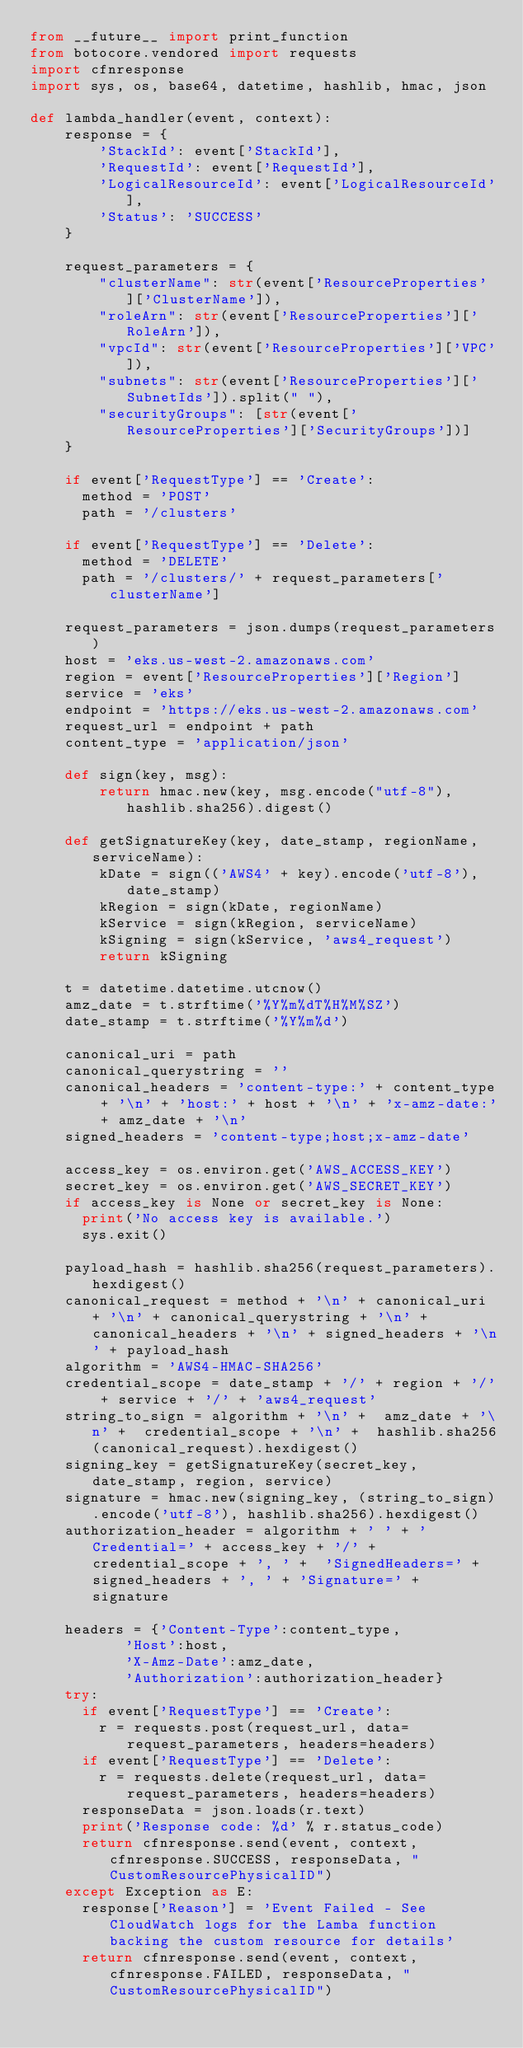Convert code to text. <code><loc_0><loc_0><loc_500><loc_500><_Python_>from __future__ import print_function
from botocore.vendored import requests
import cfnresponse
import sys, os, base64, datetime, hashlib, hmac, json

def lambda_handler(event, context):
    response = {
        'StackId': event['StackId'],
        'RequestId': event['RequestId'],
        'LogicalResourceId': event['LogicalResourceId'],
        'Status': 'SUCCESS'
    }

    request_parameters = {
        "clusterName": str(event['ResourceProperties']['ClusterName']),
        "roleArn": str(event['ResourceProperties']['RoleArn']),
        "vpcId": str(event['ResourceProperties']['VPC']),
        "subnets": str(event['ResourceProperties']['SubnetIds']).split(" "),
        "securityGroups": [str(event['ResourceProperties']['SecurityGroups'])]
    }

    if event['RequestType'] == 'Create':
      method = 'POST'
      path = '/clusters'

    if event['RequestType'] == 'Delete':
      method = 'DELETE'
      path = '/clusters/' + request_parameters['clusterName']

    request_parameters = json.dumps(request_parameters)
    host = 'eks.us-west-2.amazonaws.com'
    region = event['ResourceProperties']['Region']
    service = 'eks'
    endpoint = 'https://eks.us-west-2.amazonaws.com'
    request_url = endpoint + path
    content_type = 'application/json'

    def sign(key, msg):
        return hmac.new(key, msg.encode("utf-8"), hashlib.sha256).digest()

    def getSignatureKey(key, date_stamp, regionName, serviceName):
        kDate = sign(('AWS4' + key).encode('utf-8'), date_stamp)
        kRegion = sign(kDate, regionName)
        kService = sign(kRegion, serviceName)
        kSigning = sign(kService, 'aws4_request')
        return kSigning
    
    t = datetime.datetime.utcnow()
    amz_date = t.strftime('%Y%m%dT%H%M%SZ')
    date_stamp = t.strftime('%Y%m%d')

    canonical_uri = path
    canonical_querystring = ''               
    canonical_headers = 'content-type:' + content_type + '\n' + 'host:' + host + '\n' + 'x-amz-date:' + amz_date + '\n'
    signed_headers = 'content-type;host;x-amz-date'          
    
    access_key = os.environ.get('AWS_ACCESS_KEY')
    secret_key = os.environ.get('AWS_SECRET_KEY')
    if access_key is None or secret_key is None:
      print('No access key is available.')
      sys.exit()

    payload_hash = hashlib.sha256(request_parameters).hexdigest()
    canonical_request = method + '\n' + canonical_uri + '\n' + canonical_querystring + '\n' + canonical_headers + '\n' + signed_headers + '\n' + payload_hash
    algorithm = 'AWS4-HMAC-SHA256'
    credential_scope = date_stamp + '/' + region + '/' + service + '/' + 'aws4_request'
    string_to_sign = algorithm + '\n' +  amz_date + '\n' +  credential_scope + '\n' +  hashlib.sha256(canonical_request).hexdigest()
    signing_key = getSignatureKey(secret_key, date_stamp, region, service)
    signature = hmac.new(signing_key, (string_to_sign).encode('utf-8'), hashlib.sha256).hexdigest()
    authorization_header = algorithm + ' ' + 'Credential=' + access_key + '/' + credential_scope + ', ' +  'SignedHeaders=' + signed_headers + ', ' + 'Signature=' + signature
    
    headers = {'Content-Type':content_type,
           'Host':host,
           'X-Amz-Date':amz_date,
           'Authorization':authorization_header}
    try:
      if event['RequestType'] == 'Create':
        r = requests.post(request_url, data=request_parameters, headers=headers)
      if event['RequestType'] == 'Delete':
        r = requests.delete(request_url, data=request_parameters, headers=headers)
      responseData = json.loads(r.text)
      print('Response code: %d' % r.status_code)
      return cfnresponse.send(event, context, cfnresponse.SUCCESS, responseData, "CustomResourcePhysicalID")
    except Exception as E:
      response['Reason'] = 'Event Failed - See CloudWatch logs for the Lamba function backing the custom resource for details'
      return cfnresponse.send(event, context, cfnresponse.FAILED, responseData, "CustomResourcePhysicalID")</code> 